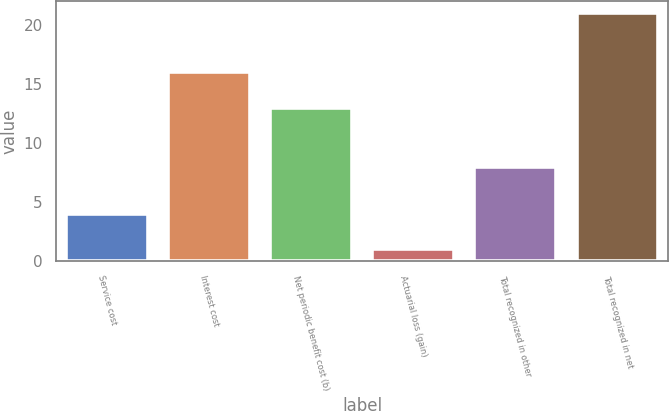Convert chart. <chart><loc_0><loc_0><loc_500><loc_500><bar_chart><fcel>Service cost<fcel>Interest cost<fcel>Net periodic benefit cost (b)<fcel>Actuarial loss (gain)<fcel>Total recognized in other<fcel>Total recognized in net<nl><fcel>4<fcel>16<fcel>13<fcel>1<fcel>8<fcel>21<nl></chart> 